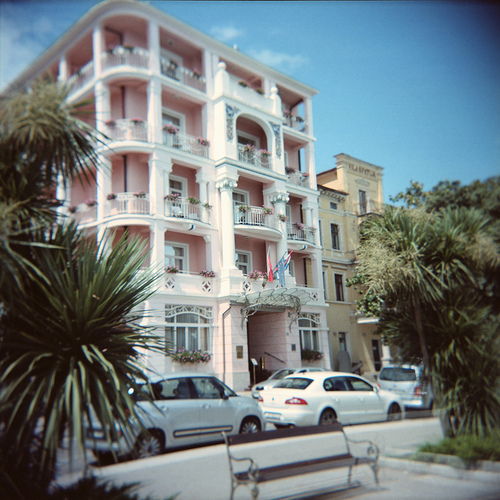<image>
Can you confirm if the car is on the building? No. The car is not positioned on the building. They may be near each other, but the car is not supported by or resting on top of the building. Is there a tree in front of the car? Yes. The tree is positioned in front of the car, appearing closer to the camera viewpoint. 